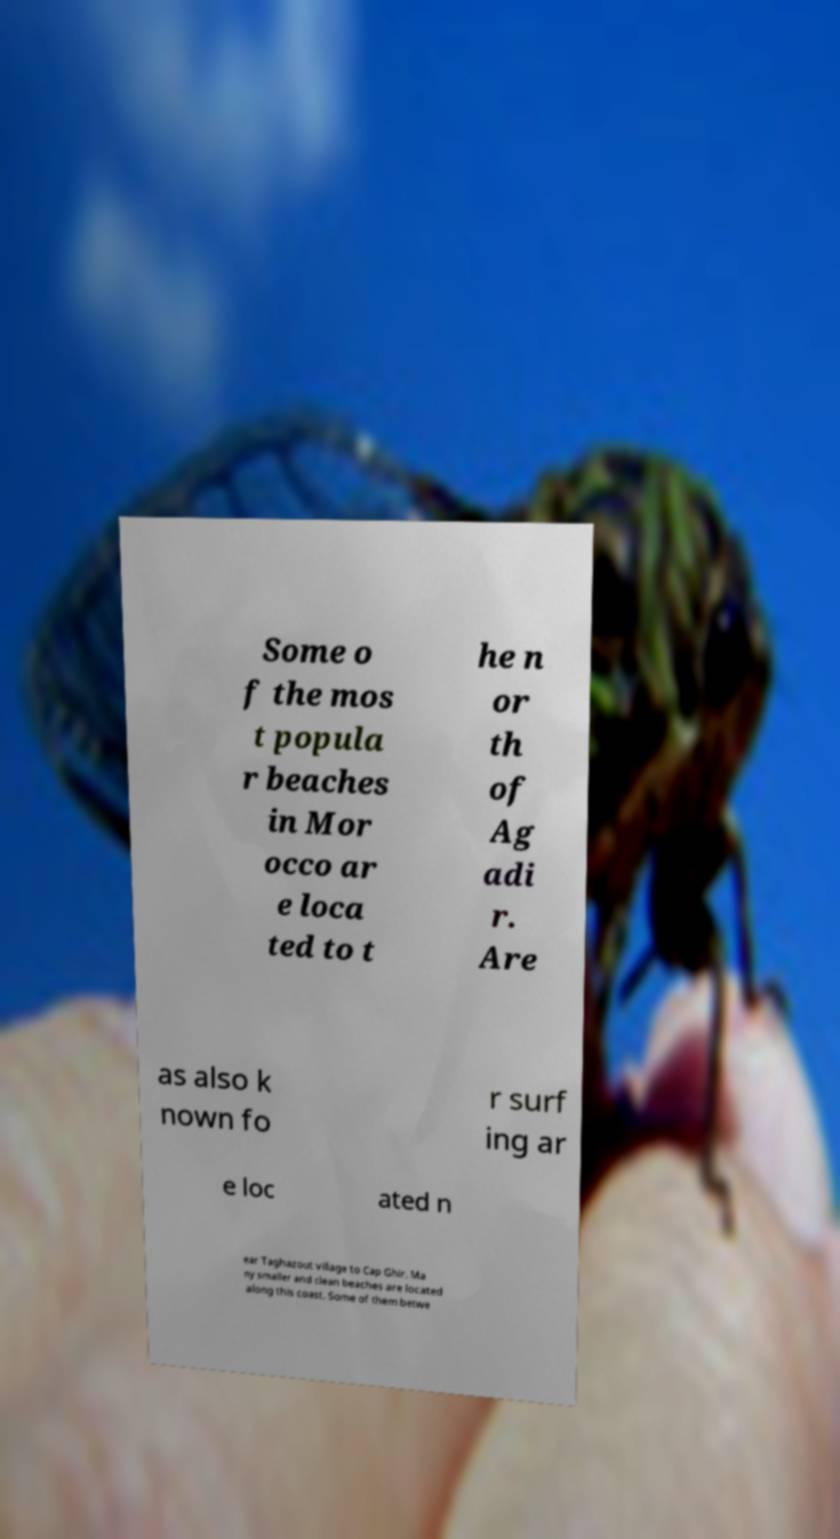I need the written content from this picture converted into text. Can you do that? Some o f the mos t popula r beaches in Mor occo ar e loca ted to t he n or th of Ag adi r. Are as also k nown fo r surf ing ar e loc ated n ear Taghazout village to Cap Ghir. Ma ny smaller and clean beaches are located along this coast. Some of them betwe 